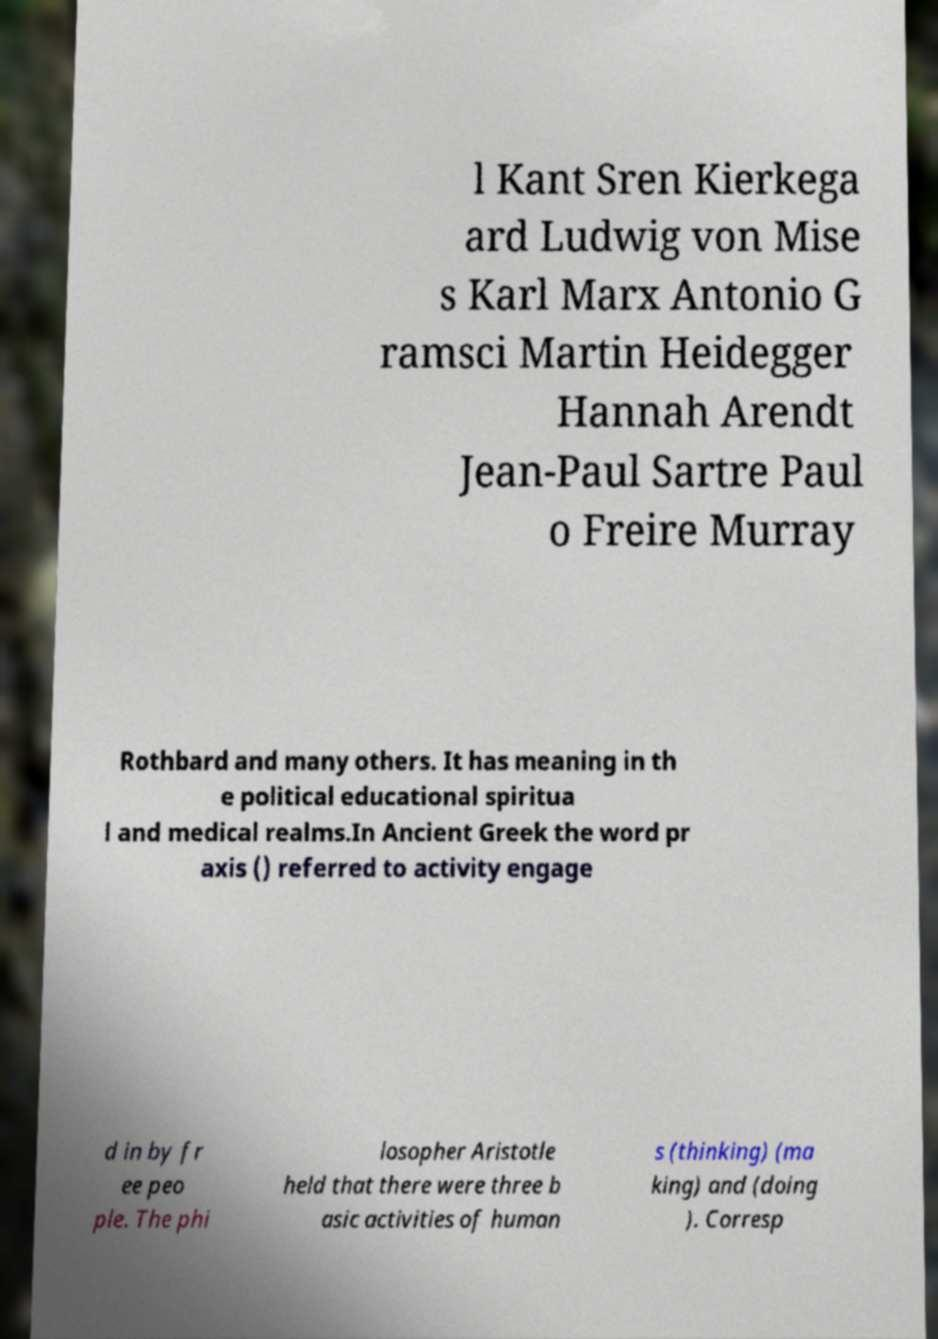Could you extract and type out the text from this image? l Kant Sren Kierkega ard Ludwig von Mise s Karl Marx Antonio G ramsci Martin Heidegger Hannah Arendt Jean-Paul Sartre Paul o Freire Murray Rothbard and many others. It has meaning in th e political educational spiritua l and medical realms.In Ancient Greek the word pr axis () referred to activity engage d in by fr ee peo ple. The phi losopher Aristotle held that there were three b asic activities of human s (thinking) (ma king) and (doing ). Corresp 